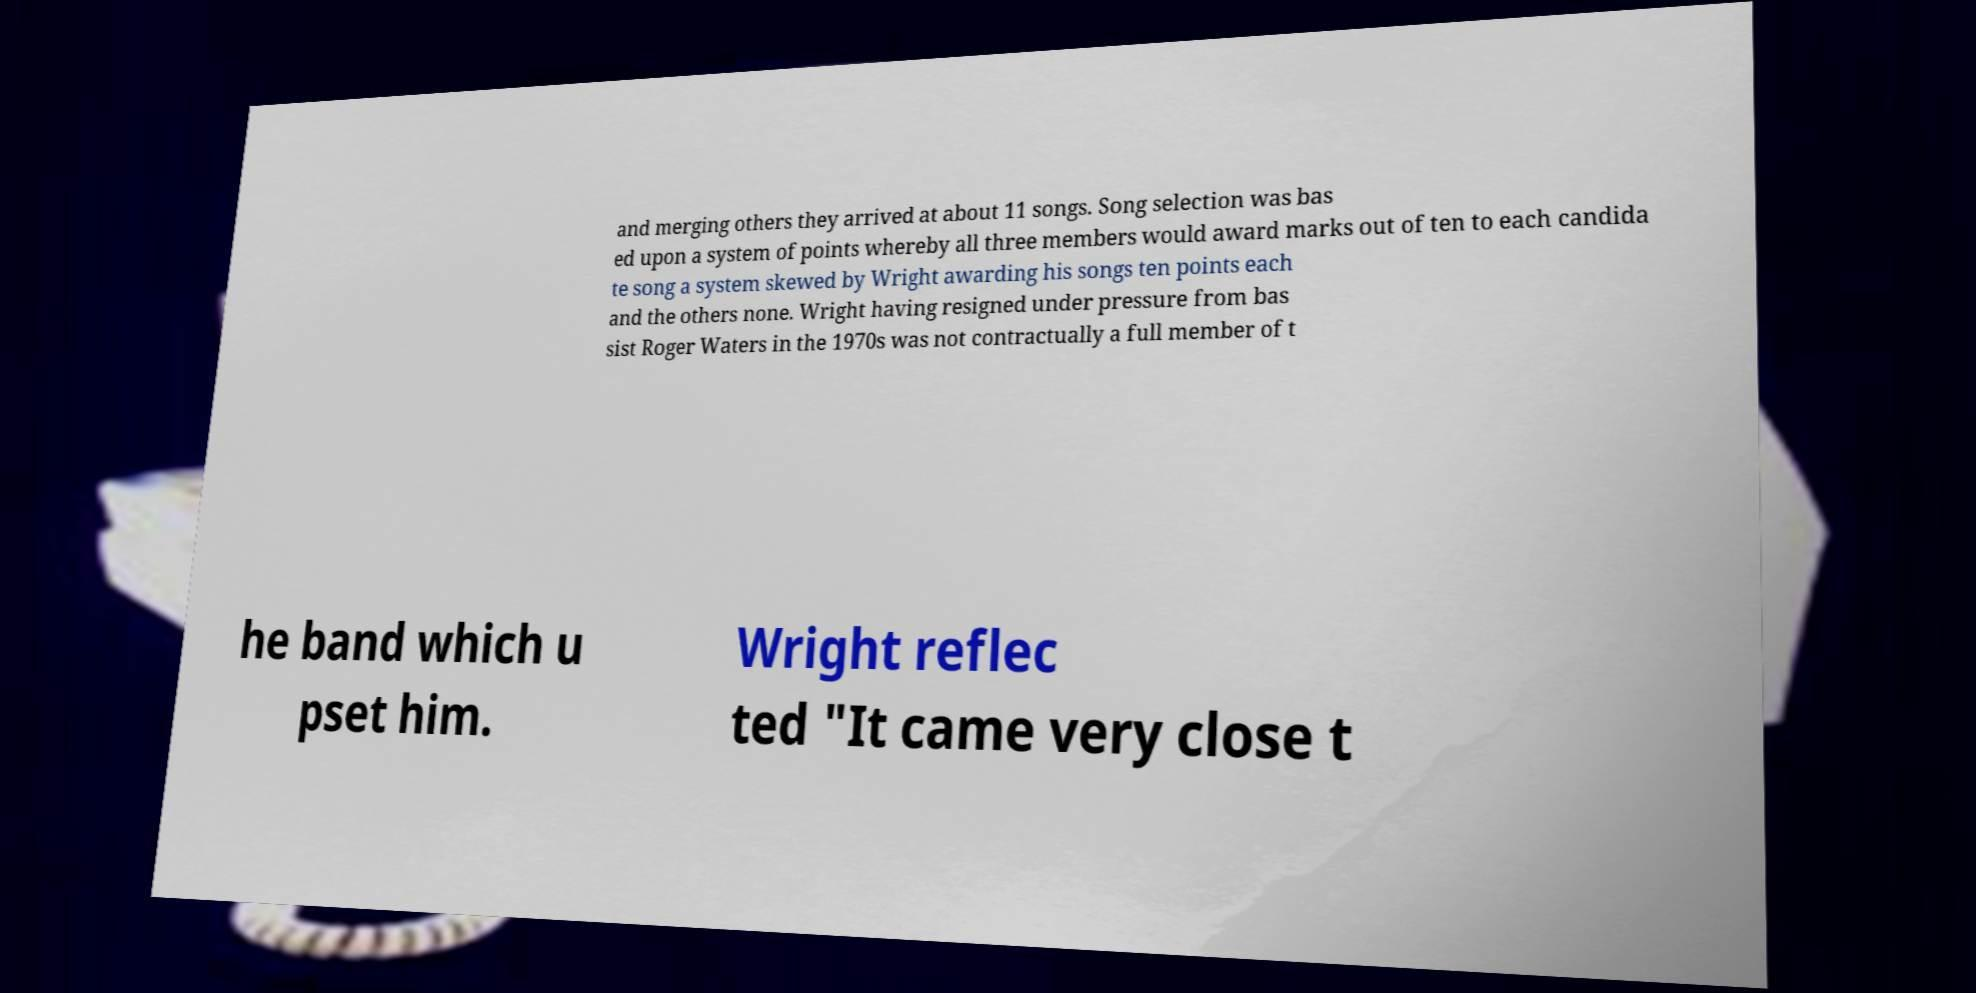Could you assist in decoding the text presented in this image and type it out clearly? and merging others they arrived at about 11 songs. Song selection was bas ed upon a system of points whereby all three members would award marks out of ten to each candida te song a system skewed by Wright awarding his songs ten points each and the others none. Wright having resigned under pressure from bas sist Roger Waters in the 1970s was not contractually a full member of t he band which u pset him. Wright reflec ted "It came very close t 